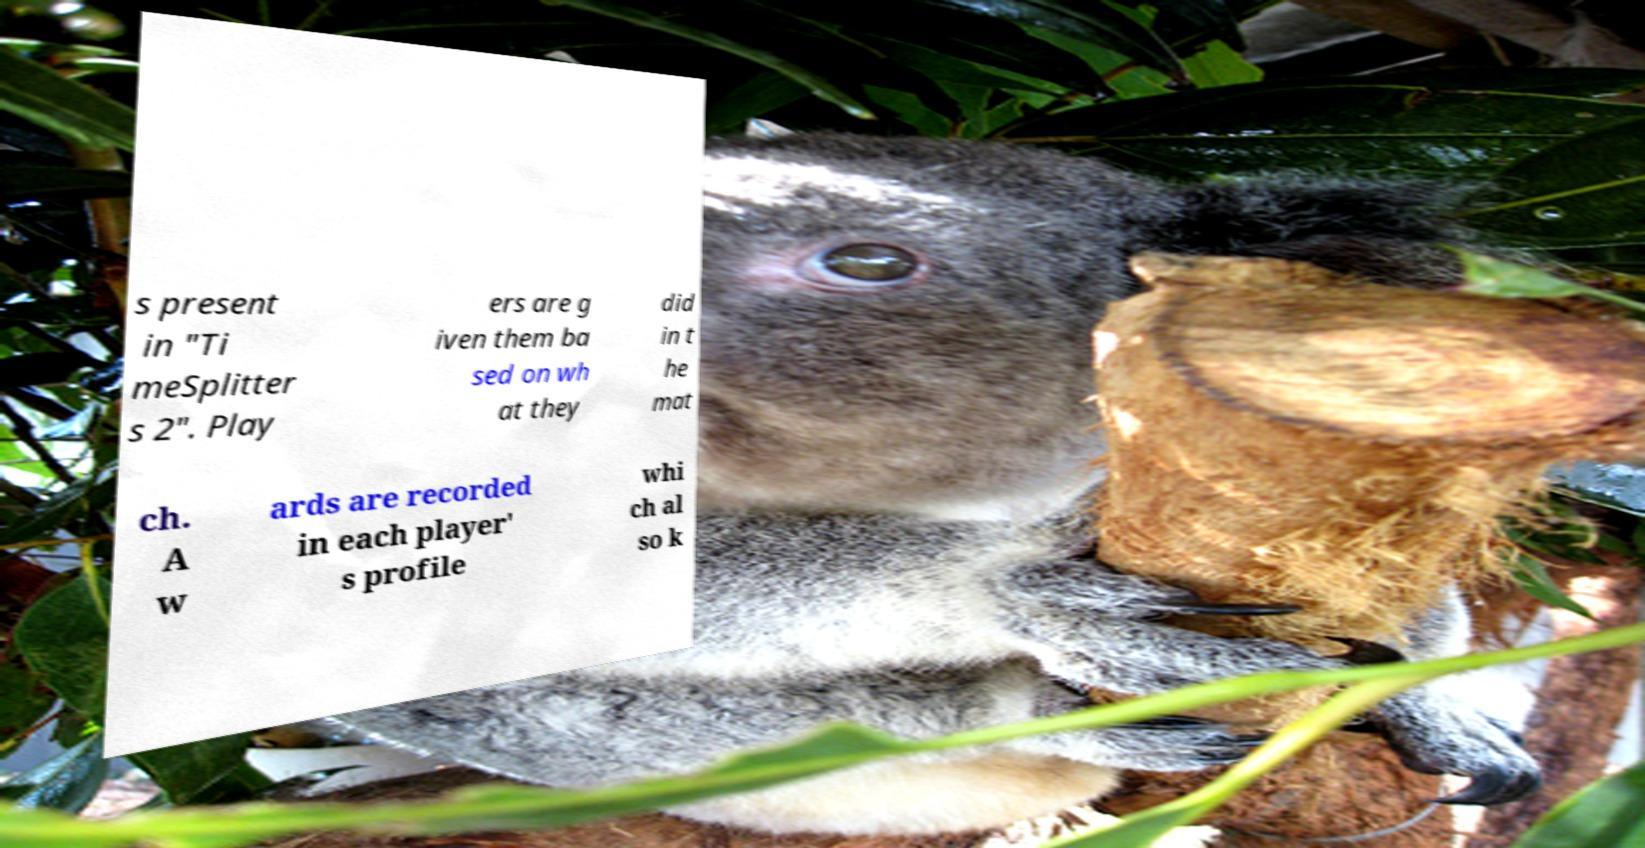Could you assist in decoding the text presented in this image and type it out clearly? s present in "Ti meSplitter s 2". Play ers are g iven them ba sed on wh at they did in t he mat ch. A w ards are recorded in each player' s profile whi ch al so k 